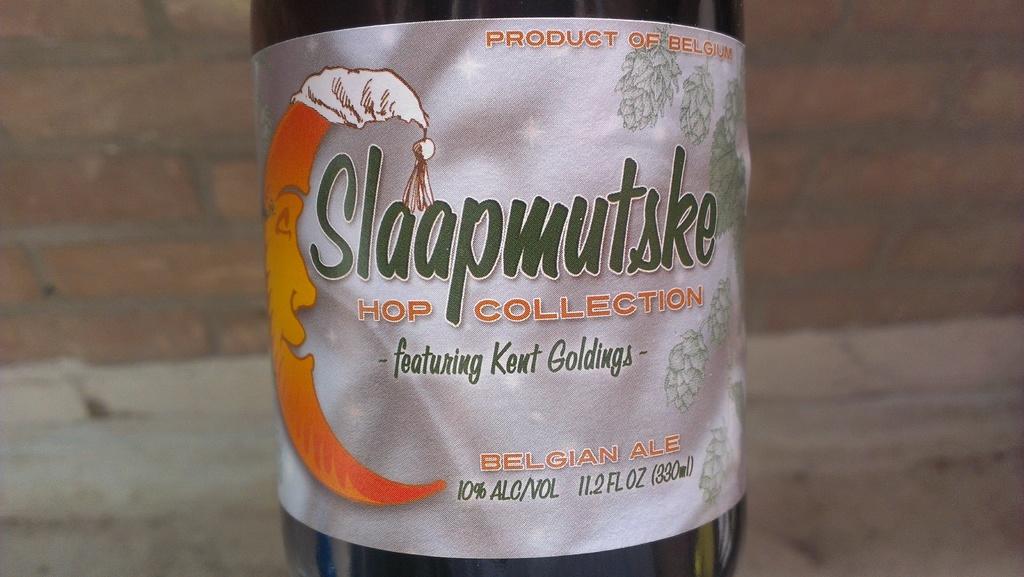What is the name of the bottle?
Provide a succinct answer. Slaapmutske. 